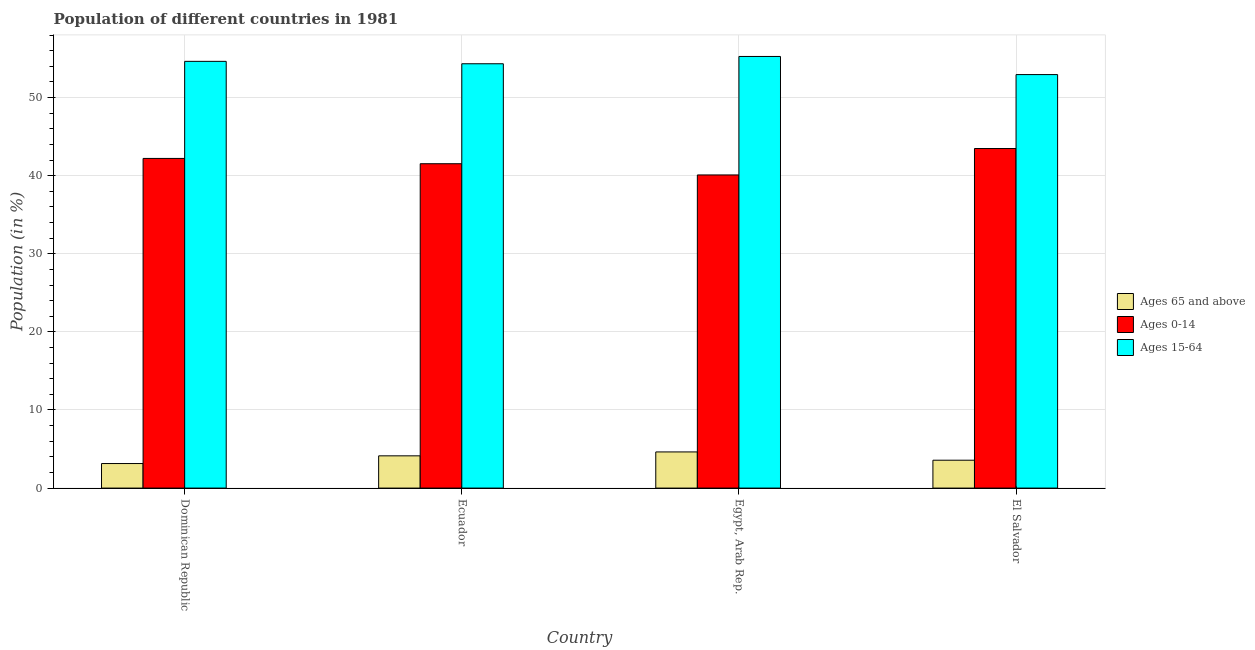Are the number of bars per tick equal to the number of legend labels?
Your answer should be very brief. Yes. Are the number of bars on each tick of the X-axis equal?
Keep it short and to the point. Yes. How many bars are there on the 4th tick from the right?
Keep it short and to the point. 3. What is the label of the 4th group of bars from the left?
Ensure brevity in your answer.  El Salvador. In how many cases, is the number of bars for a given country not equal to the number of legend labels?
Your answer should be very brief. 0. What is the percentage of population within the age-group of 65 and above in El Salvador?
Ensure brevity in your answer.  3.57. Across all countries, what is the maximum percentage of population within the age-group of 65 and above?
Provide a succinct answer. 4.63. Across all countries, what is the minimum percentage of population within the age-group 15-64?
Your response must be concise. 52.95. In which country was the percentage of population within the age-group 15-64 maximum?
Your answer should be compact. Egypt, Arab Rep. In which country was the percentage of population within the age-group of 65 and above minimum?
Keep it short and to the point. Dominican Republic. What is the total percentage of population within the age-group of 65 and above in the graph?
Your answer should be compact. 15.47. What is the difference between the percentage of population within the age-group 0-14 in Dominican Republic and that in El Salvador?
Offer a terse response. -1.27. What is the difference between the percentage of population within the age-group 15-64 in Ecuador and the percentage of population within the age-group 0-14 in Egypt, Arab Rep.?
Ensure brevity in your answer.  14.24. What is the average percentage of population within the age-group of 65 and above per country?
Provide a short and direct response. 3.87. What is the difference between the percentage of population within the age-group of 65 and above and percentage of population within the age-group 0-14 in Dominican Republic?
Give a very brief answer. -39.07. What is the ratio of the percentage of population within the age-group of 65 and above in Dominican Republic to that in El Salvador?
Make the answer very short. 0.88. What is the difference between the highest and the second highest percentage of population within the age-group 0-14?
Offer a terse response. 1.27. What is the difference between the highest and the lowest percentage of population within the age-group 0-14?
Your answer should be very brief. 3.38. Is the sum of the percentage of population within the age-group 0-14 in Dominican Republic and Ecuador greater than the maximum percentage of population within the age-group 15-64 across all countries?
Ensure brevity in your answer.  Yes. What does the 3rd bar from the left in Dominican Republic represents?
Keep it short and to the point. Ages 15-64. What does the 2nd bar from the right in Egypt, Arab Rep. represents?
Keep it short and to the point. Ages 0-14. Is it the case that in every country, the sum of the percentage of population within the age-group of 65 and above and percentage of population within the age-group 0-14 is greater than the percentage of population within the age-group 15-64?
Keep it short and to the point. No. How many bars are there?
Your answer should be very brief. 12. Are all the bars in the graph horizontal?
Ensure brevity in your answer.  No. How many countries are there in the graph?
Provide a short and direct response. 4. What is the difference between two consecutive major ticks on the Y-axis?
Keep it short and to the point. 10. Does the graph contain grids?
Your answer should be compact. Yes. Where does the legend appear in the graph?
Give a very brief answer. Center right. How are the legend labels stacked?
Offer a terse response. Vertical. What is the title of the graph?
Provide a succinct answer. Population of different countries in 1981. Does "Ages 50+" appear as one of the legend labels in the graph?
Make the answer very short. No. What is the label or title of the X-axis?
Keep it short and to the point. Country. What is the label or title of the Y-axis?
Your answer should be compact. Population (in %). What is the Population (in %) of Ages 65 and above in Dominican Republic?
Ensure brevity in your answer.  3.14. What is the Population (in %) in Ages 0-14 in Dominican Republic?
Offer a very short reply. 42.21. What is the Population (in %) in Ages 15-64 in Dominican Republic?
Ensure brevity in your answer.  54.64. What is the Population (in %) in Ages 65 and above in Ecuador?
Make the answer very short. 4.13. What is the Population (in %) of Ages 0-14 in Ecuador?
Provide a succinct answer. 41.53. What is the Population (in %) in Ages 15-64 in Ecuador?
Ensure brevity in your answer.  54.34. What is the Population (in %) of Ages 65 and above in Egypt, Arab Rep.?
Ensure brevity in your answer.  4.63. What is the Population (in %) in Ages 0-14 in Egypt, Arab Rep.?
Your response must be concise. 40.1. What is the Population (in %) in Ages 15-64 in Egypt, Arab Rep.?
Offer a very short reply. 55.27. What is the Population (in %) in Ages 65 and above in El Salvador?
Make the answer very short. 3.57. What is the Population (in %) of Ages 0-14 in El Salvador?
Give a very brief answer. 43.48. What is the Population (in %) in Ages 15-64 in El Salvador?
Provide a short and direct response. 52.95. Across all countries, what is the maximum Population (in %) of Ages 65 and above?
Ensure brevity in your answer.  4.63. Across all countries, what is the maximum Population (in %) of Ages 0-14?
Make the answer very short. 43.48. Across all countries, what is the maximum Population (in %) in Ages 15-64?
Your answer should be compact. 55.27. Across all countries, what is the minimum Population (in %) of Ages 65 and above?
Your answer should be very brief. 3.14. Across all countries, what is the minimum Population (in %) of Ages 0-14?
Provide a short and direct response. 40.1. Across all countries, what is the minimum Population (in %) of Ages 15-64?
Provide a short and direct response. 52.95. What is the total Population (in %) of Ages 65 and above in the graph?
Ensure brevity in your answer.  15.47. What is the total Population (in %) in Ages 0-14 in the graph?
Offer a very short reply. 167.33. What is the total Population (in %) of Ages 15-64 in the graph?
Provide a succinct answer. 217.2. What is the difference between the Population (in %) in Ages 65 and above in Dominican Republic and that in Ecuador?
Ensure brevity in your answer.  -0.99. What is the difference between the Population (in %) in Ages 0-14 in Dominican Republic and that in Ecuador?
Provide a succinct answer. 0.68. What is the difference between the Population (in %) of Ages 15-64 in Dominican Republic and that in Ecuador?
Ensure brevity in your answer.  0.31. What is the difference between the Population (in %) in Ages 65 and above in Dominican Republic and that in Egypt, Arab Rep.?
Your response must be concise. -1.49. What is the difference between the Population (in %) of Ages 0-14 in Dominican Republic and that in Egypt, Arab Rep.?
Provide a succinct answer. 2.11. What is the difference between the Population (in %) in Ages 15-64 in Dominican Republic and that in Egypt, Arab Rep.?
Give a very brief answer. -0.63. What is the difference between the Population (in %) of Ages 65 and above in Dominican Republic and that in El Salvador?
Offer a terse response. -0.43. What is the difference between the Population (in %) in Ages 0-14 in Dominican Republic and that in El Salvador?
Offer a very short reply. -1.27. What is the difference between the Population (in %) in Ages 15-64 in Dominican Republic and that in El Salvador?
Offer a very short reply. 1.69. What is the difference between the Population (in %) of Ages 65 and above in Ecuador and that in Egypt, Arab Rep.?
Offer a terse response. -0.5. What is the difference between the Population (in %) in Ages 0-14 in Ecuador and that in Egypt, Arab Rep.?
Offer a terse response. 1.44. What is the difference between the Population (in %) of Ages 15-64 in Ecuador and that in Egypt, Arab Rep.?
Make the answer very short. -0.94. What is the difference between the Population (in %) in Ages 65 and above in Ecuador and that in El Salvador?
Provide a short and direct response. 0.56. What is the difference between the Population (in %) of Ages 0-14 in Ecuador and that in El Salvador?
Make the answer very short. -1.95. What is the difference between the Population (in %) of Ages 15-64 in Ecuador and that in El Salvador?
Make the answer very short. 1.39. What is the difference between the Population (in %) in Ages 65 and above in Egypt, Arab Rep. and that in El Salvador?
Your answer should be compact. 1.06. What is the difference between the Population (in %) of Ages 0-14 in Egypt, Arab Rep. and that in El Salvador?
Offer a terse response. -3.38. What is the difference between the Population (in %) in Ages 15-64 in Egypt, Arab Rep. and that in El Salvador?
Give a very brief answer. 2.32. What is the difference between the Population (in %) in Ages 65 and above in Dominican Republic and the Population (in %) in Ages 0-14 in Ecuador?
Give a very brief answer. -38.39. What is the difference between the Population (in %) of Ages 65 and above in Dominican Republic and the Population (in %) of Ages 15-64 in Ecuador?
Provide a succinct answer. -51.19. What is the difference between the Population (in %) in Ages 0-14 in Dominican Republic and the Population (in %) in Ages 15-64 in Ecuador?
Offer a very short reply. -12.12. What is the difference between the Population (in %) of Ages 65 and above in Dominican Republic and the Population (in %) of Ages 0-14 in Egypt, Arab Rep.?
Your answer should be very brief. -36.96. What is the difference between the Population (in %) in Ages 65 and above in Dominican Republic and the Population (in %) in Ages 15-64 in Egypt, Arab Rep.?
Provide a short and direct response. -52.13. What is the difference between the Population (in %) of Ages 0-14 in Dominican Republic and the Population (in %) of Ages 15-64 in Egypt, Arab Rep.?
Your answer should be very brief. -13.06. What is the difference between the Population (in %) in Ages 65 and above in Dominican Republic and the Population (in %) in Ages 0-14 in El Salvador?
Keep it short and to the point. -40.34. What is the difference between the Population (in %) of Ages 65 and above in Dominican Republic and the Population (in %) of Ages 15-64 in El Salvador?
Your answer should be compact. -49.81. What is the difference between the Population (in %) of Ages 0-14 in Dominican Republic and the Population (in %) of Ages 15-64 in El Salvador?
Offer a terse response. -10.74. What is the difference between the Population (in %) of Ages 65 and above in Ecuador and the Population (in %) of Ages 0-14 in Egypt, Arab Rep.?
Give a very brief answer. -35.97. What is the difference between the Population (in %) of Ages 65 and above in Ecuador and the Population (in %) of Ages 15-64 in Egypt, Arab Rep.?
Your answer should be very brief. -51.14. What is the difference between the Population (in %) of Ages 0-14 in Ecuador and the Population (in %) of Ages 15-64 in Egypt, Arab Rep.?
Offer a terse response. -13.74. What is the difference between the Population (in %) of Ages 65 and above in Ecuador and the Population (in %) of Ages 0-14 in El Salvador?
Your response must be concise. -39.35. What is the difference between the Population (in %) of Ages 65 and above in Ecuador and the Population (in %) of Ages 15-64 in El Salvador?
Give a very brief answer. -48.82. What is the difference between the Population (in %) of Ages 0-14 in Ecuador and the Population (in %) of Ages 15-64 in El Salvador?
Your answer should be compact. -11.41. What is the difference between the Population (in %) of Ages 65 and above in Egypt, Arab Rep. and the Population (in %) of Ages 0-14 in El Salvador?
Your answer should be very brief. -38.85. What is the difference between the Population (in %) of Ages 65 and above in Egypt, Arab Rep. and the Population (in %) of Ages 15-64 in El Salvador?
Give a very brief answer. -48.32. What is the difference between the Population (in %) of Ages 0-14 in Egypt, Arab Rep. and the Population (in %) of Ages 15-64 in El Salvador?
Your response must be concise. -12.85. What is the average Population (in %) in Ages 65 and above per country?
Offer a very short reply. 3.87. What is the average Population (in %) in Ages 0-14 per country?
Offer a very short reply. 41.83. What is the average Population (in %) in Ages 15-64 per country?
Provide a short and direct response. 54.3. What is the difference between the Population (in %) in Ages 65 and above and Population (in %) in Ages 0-14 in Dominican Republic?
Your answer should be very brief. -39.07. What is the difference between the Population (in %) in Ages 65 and above and Population (in %) in Ages 15-64 in Dominican Republic?
Make the answer very short. -51.5. What is the difference between the Population (in %) of Ages 0-14 and Population (in %) of Ages 15-64 in Dominican Republic?
Keep it short and to the point. -12.43. What is the difference between the Population (in %) of Ages 65 and above and Population (in %) of Ages 0-14 in Ecuador?
Your answer should be very brief. -37.4. What is the difference between the Population (in %) in Ages 65 and above and Population (in %) in Ages 15-64 in Ecuador?
Your answer should be compact. -50.2. What is the difference between the Population (in %) in Ages 0-14 and Population (in %) in Ages 15-64 in Ecuador?
Your answer should be very brief. -12.8. What is the difference between the Population (in %) in Ages 65 and above and Population (in %) in Ages 0-14 in Egypt, Arab Rep.?
Your response must be concise. -35.47. What is the difference between the Population (in %) in Ages 65 and above and Population (in %) in Ages 15-64 in Egypt, Arab Rep.?
Ensure brevity in your answer.  -50.64. What is the difference between the Population (in %) in Ages 0-14 and Population (in %) in Ages 15-64 in Egypt, Arab Rep.?
Offer a very short reply. -15.17. What is the difference between the Population (in %) of Ages 65 and above and Population (in %) of Ages 0-14 in El Salvador?
Ensure brevity in your answer.  -39.91. What is the difference between the Population (in %) in Ages 65 and above and Population (in %) in Ages 15-64 in El Salvador?
Make the answer very short. -49.38. What is the difference between the Population (in %) of Ages 0-14 and Population (in %) of Ages 15-64 in El Salvador?
Make the answer very short. -9.47. What is the ratio of the Population (in %) of Ages 65 and above in Dominican Republic to that in Ecuador?
Give a very brief answer. 0.76. What is the ratio of the Population (in %) of Ages 0-14 in Dominican Republic to that in Ecuador?
Make the answer very short. 1.02. What is the ratio of the Population (in %) of Ages 15-64 in Dominican Republic to that in Ecuador?
Offer a very short reply. 1.01. What is the ratio of the Population (in %) in Ages 65 and above in Dominican Republic to that in Egypt, Arab Rep.?
Give a very brief answer. 0.68. What is the ratio of the Population (in %) of Ages 0-14 in Dominican Republic to that in Egypt, Arab Rep.?
Keep it short and to the point. 1.05. What is the ratio of the Population (in %) of Ages 15-64 in Dominican Republic to that in Egypt, Arab Rep.?
Your answer should be very brief. 0.99. What is the ratio of the Population (in %) in Ages 65 and above in Dominican Republic to that in El Salvador?
Keep it short and to the point. 0.88. What is the ratio of the Population (in %) in Ages 0-14 in Dominican Republic to that in El Salvador?
Keep it short and to the point. 0.97. What is the ratio of the Population (in %) in Ages 15-64 in Dominican Republic to that in El Salvador?
Provide a short and direct response. 1.03. What is the ratio of the Population (in %) in Ages 65 and above in Ecuador to that in Egypt, Arab Rep.?
Make the answer very short. 0.89. What is the ratio of the Population (in %) of Ages 0-14 in Ecuador to that in Egypt, Arab Rep.?
Give a very brief answer. 1.04. What is the ratio of the Population (in %) in Ages 15-64 in Ecuador to that in Egypt, Arab Rep.?
Provide a short and direct response. 0.98. What is the ratio of the Population (in %) of Ages 65 and above in Ecuador to that in El Salvador?
Offer a terse response. 1.16. What is the ratio of the Population (in %) in Ages 0-14 in Ecuador to that in El Salvador?
Your answer should be compact. 0.96. What is the ratio of the Population (in %) of Ages 15-64 in Ecuador to that in El Salvador?
Provide a succinct answer. 1.03. What is the ratio of the Population (in %) in Ages 65 and above in Egypt, Arab Rep. to that in El Salvador?
Make the answer very short. 1.3. What is the ratio of the Population (in %) of Ages 0-14 in Egypt, Arab Rep. to that in El Salvador?
Provide a short and direct response. 0.92. What is the ratio of the Population (in %) of Ages 15-64 in Egypt, Arab Rep. to that in El Salvador?
Offer a very short reply. 1.04. What is the difference between the highest and the second highest Population (in %) in Ages 65 and above?
Offer a very short reply. 0.5. What is the difference between the highest and the second highest Population (in %) of Ages 0-14?
Give a very brief answer. 1.27. What is the difference between the highest and the second highest Population (in %) of Ages 15-64?
Make the answer very short. 0.63. What is the difference between the highest and the lowest Population (in %) of Ages 65 and above?
Offer a terse response. 1.49. What is the difference between the highest and the lowest Population (in %) in Ages 0-14?
Provide a succinct answer. 3.38. What is the difference between the highest and the lowest Population (in %) in Ages 15-64?
Offer a terse response. 2.32. 